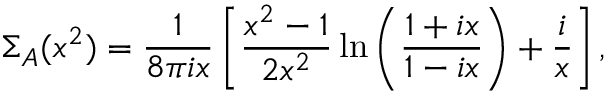Convert formula to latex. <formula><loc_0><loc_0><loc_500><loc_500>\Sigma _ { A } ( x ^ { 2 } ) = \frac { 1 } { 8 \pi i x } \left [ \frac { x ^ { 2 } - 1 } { 2 x ^ { 2 } } \ln \left ( \frac { 1 + i x } { 1 - i x } \right ) + \frac { i } { x } \right ] ,</formula> 